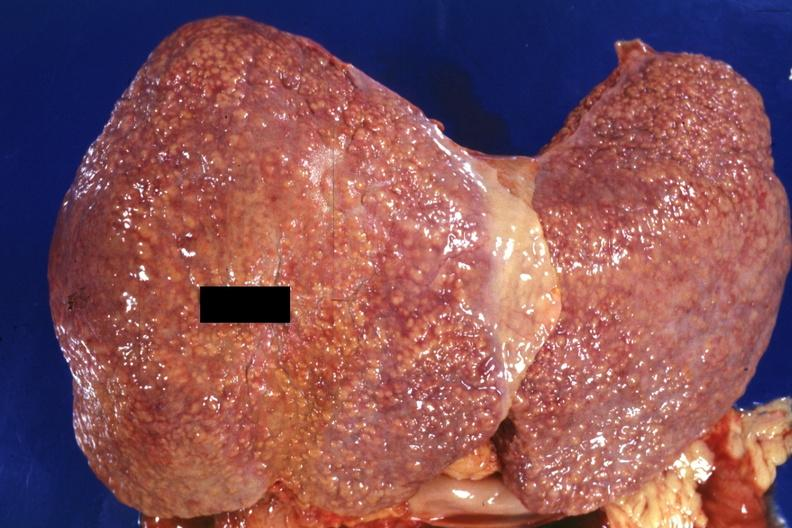what does this image show?
Answer the question using a single word or phrase. External view of large liver with obvious cirrhosis excellent example 